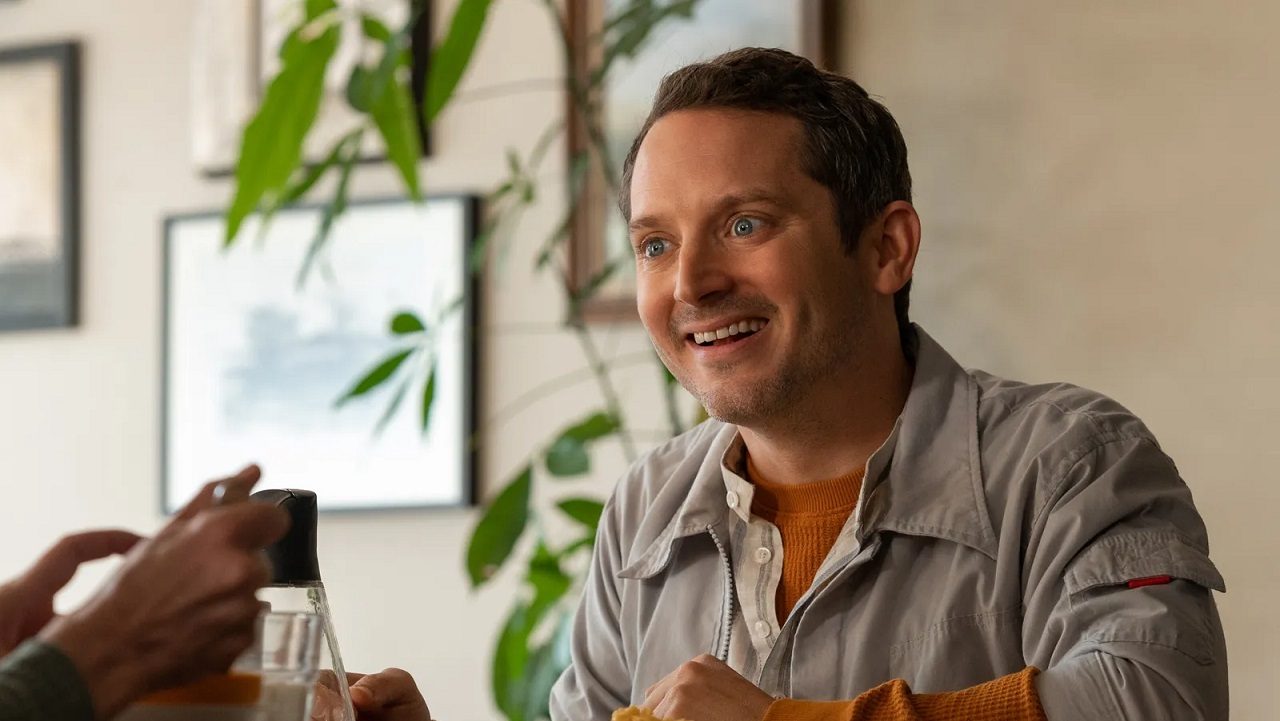Describe a detailed realistic scenario involving the person in the image. Ethan had a long day at work, filled with back-to-back meetings and looming deadlines. Seeking respite, he decides to stop by his favorite café on the way home. As he enters, he's greeted by the familiar aroma of freshly brewed coffee and the serene ambiance created by the greenery scattered throughout the space. Spotting his friend Lucas seated at their usual table, Ethan's face lights up with a smile. They had planned this meet-up days in advance, desperately needing a break to decompress. Over cappuccinos, they chat about their lives, share stories from work, and discuss their plans for an upcoming vacation. Lucas mentions a new hiking trail he discovered, and they make a pact to explore it next weekend. For a moment, all the stresses of the day fade away, replaced by the warmth of friendship and the comfort of familiar surroundings. 